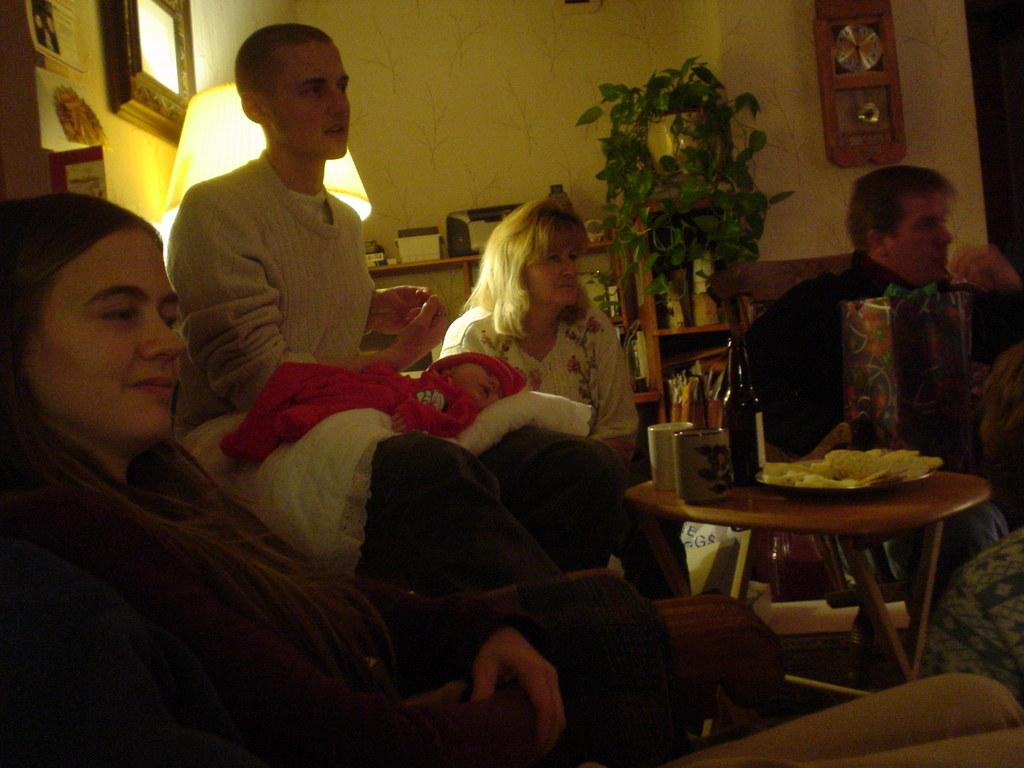What are the people in the image doing? The people in the image are sitting. What can be seen on the table in the image? There are two cups and food on a plate on the table. What is visible in the background of the image? There is a plant in the background of the image. What type of engine can be seen in the image? There is no engine present in the image. How many people are smiling in the image? The provided facts do not mention anyone smiling in the image. 